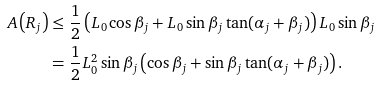Convert formula to latex. <formula><loc_0><loc_0><loc_500><loc_500>A \left ( R _ { j } \right ) & \leq \frac { 1 } { 2 } \left ( L _ { 0 } \cos \beta _ { j } + L _ { 0 } \sin \beta _ { j } \tan ( \alpha _ { j } + \beta _ { j } ) \right ) L _ { 0 } \sin \beta _ { j } \\ & = \frac { 1 } { 2 } L _ { 0 } ^ { 2 } \sin \beta _ { j } \left ( \cos \beta _ { j } + \sin \beta _ { j } \tan ( \alpha _ { j } + \beta _ { j } ) \right ) .</formula> 